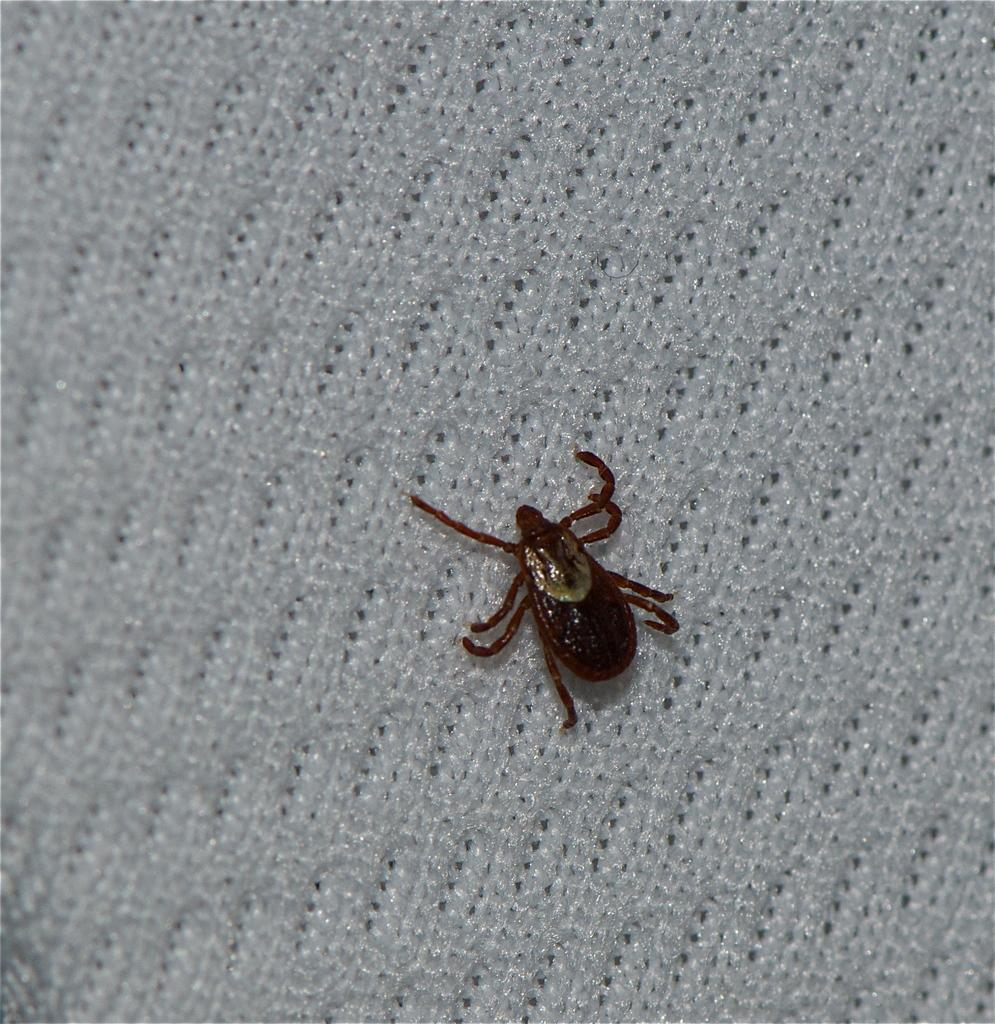What type of animal is present in the image? There is a Dermacentor in the image. What is located at the bottom of the image? There is a cloth in the image, located at the bottom. What type of bomb is present in the image? There is no bomb present in the image; it features a Dermacentor and a cloth. How does the Dermacentor affect the nerves in the image? The image does not depict the Dermacentor affecting any nerves, as it is a static image. 